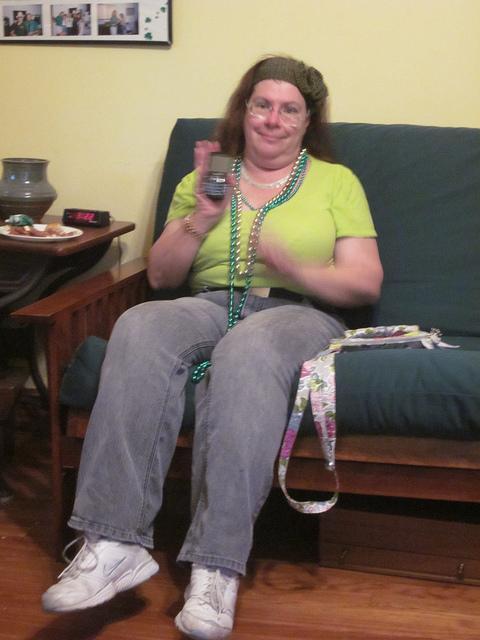How many necklaces is the woman wearing?
Give a very brief answer. 3. How many trains are there?
Give a very brief answer. 0. 